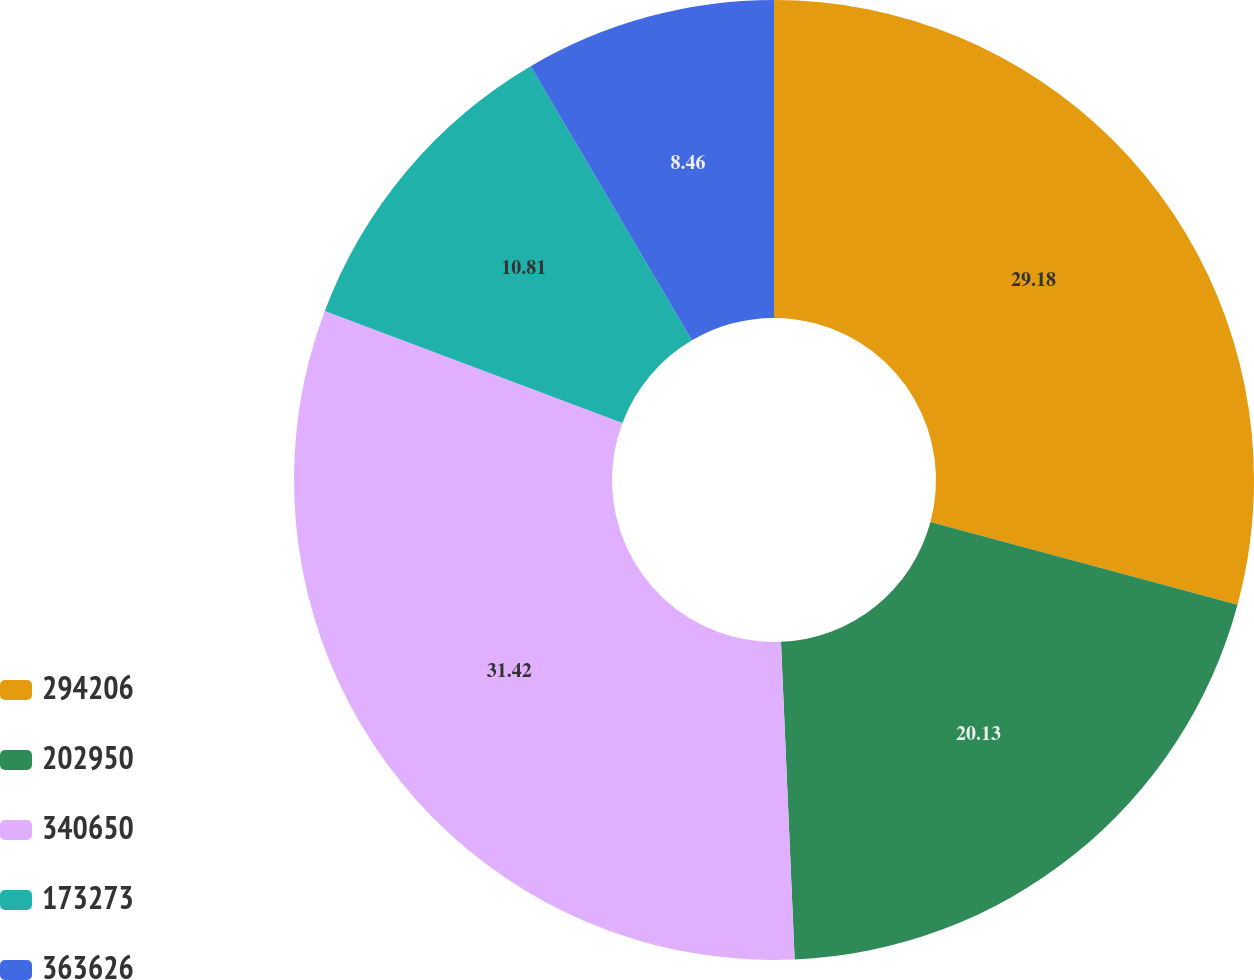Convert chart to OTSL. <chart><loc_0><loc_0><loc_500><loc_500><pie_chart><fcel>294206<fcel>202950<fcel>340650<fcel>173273<fcel>363626<nl><fcel>29.18%<fcel>20.13%<fcel>31.41%<fcel>10.81%<fcel>8.46%<nl></chart> 